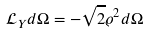<formula> <loc_0><loc_0><loc_500><loc_500>\mathcal { L } _ { Y } d \Omega = - \sqrt { 2 } \varrho ^ { 2 } d \Omega</formula> 